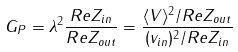<formula> <loc_0><loc_0><loc_500><loc_500>G _ { P } = \lambda ^ { 2 } \frac { R e Z _ { i n } } { R e Z _ { o u t } } = \frac { \langle V \rangle ^ { 2 } / R e Z _ { o u t } } { ( v _ { i n } ) ^ { 2 } / R e Z _ { i n } }</formula> 